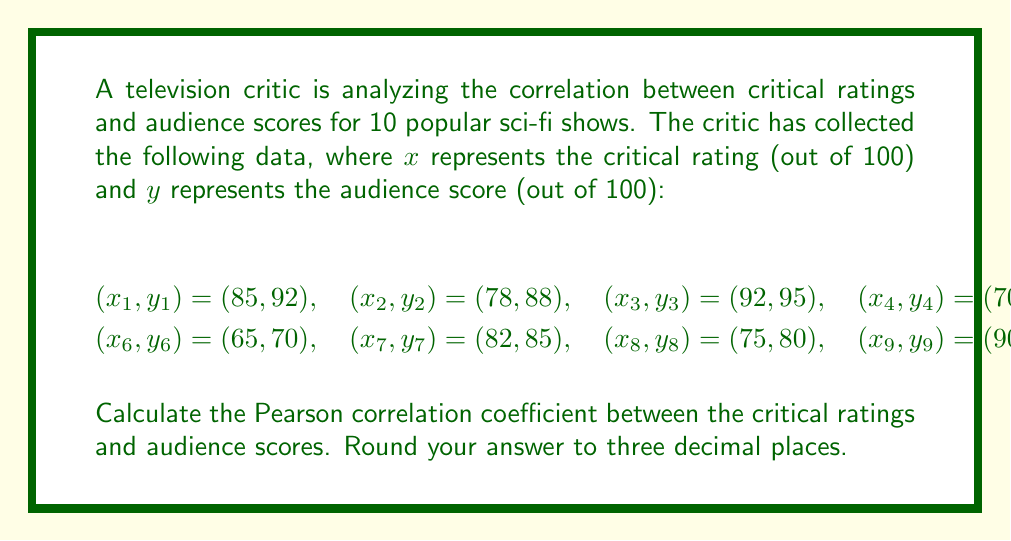Teach me how to tackle this problem. To calculate the Pearson correlation coefficient, we'll use the formula:

$$r = \frac{\sum_{i=1}^{n} (x_i - \bar{x})(y_i - \bar{y})}{\sqrt{\sum_{i=1}^{n} (x_i - \bar{x})^2 \sum_{i=1}^{n} (y_i - \bar{y})^2}}$$

Where $\bar{x}$ and $\bar{y}$ are the means of $x$ and $y$ respectively.

Step 1: Calculate the means
$\bar{x} = \frac{85 + 78 + 92 + 70 + 88 + 65 + 82 + 75 + 90 + 80}{10} = 80.5$
$\bar{y} = \frac{92 + 88 + 95 + 75 + 90 + 70 + 85 + 80 + 93 + 87}{10} = 85.5$

Step 2: Calculate $(x_i - \bar{x})$, $(y_i - \bar{y})$, $(x_i - \bar{x})^2$, $(y_i - \bar{y})^2$, and $(x_i - \bar{x})(y_i - \bar{y})$ for each pair

Step 3: Sum up the values
$\sum (x_i - \bar{x})(y_i - \bar{y}) = 625.5$
$\sum (x_i - \bar{x})^2 = 812.5$
$\sum (y_i - \bar{y})^2 = 602.5$

Step 4: Apply the formula
$$r = \frac{625.5}{\sqrt{812.5 \times 602.5}} = \frac{625.5}{699.638} \approx 0.894$$

Step 5: Round to three decimal places
$r \approx 0.894$
Answer: 0.894 